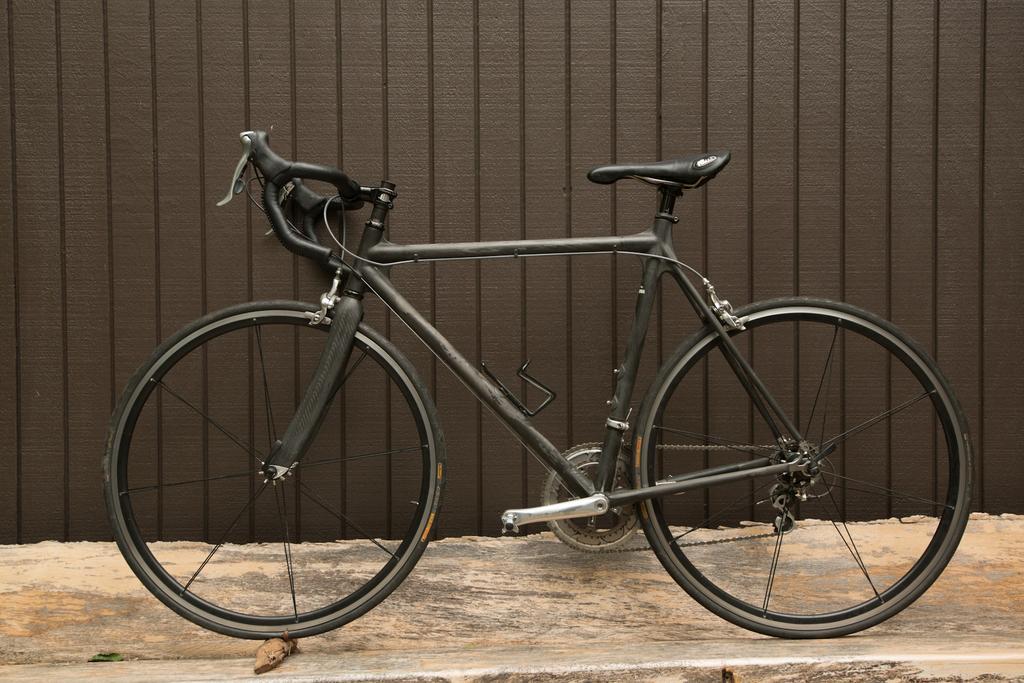Could you give a brief overview of what you see in this image? In this picture there is a bicycle in the center of the image. 